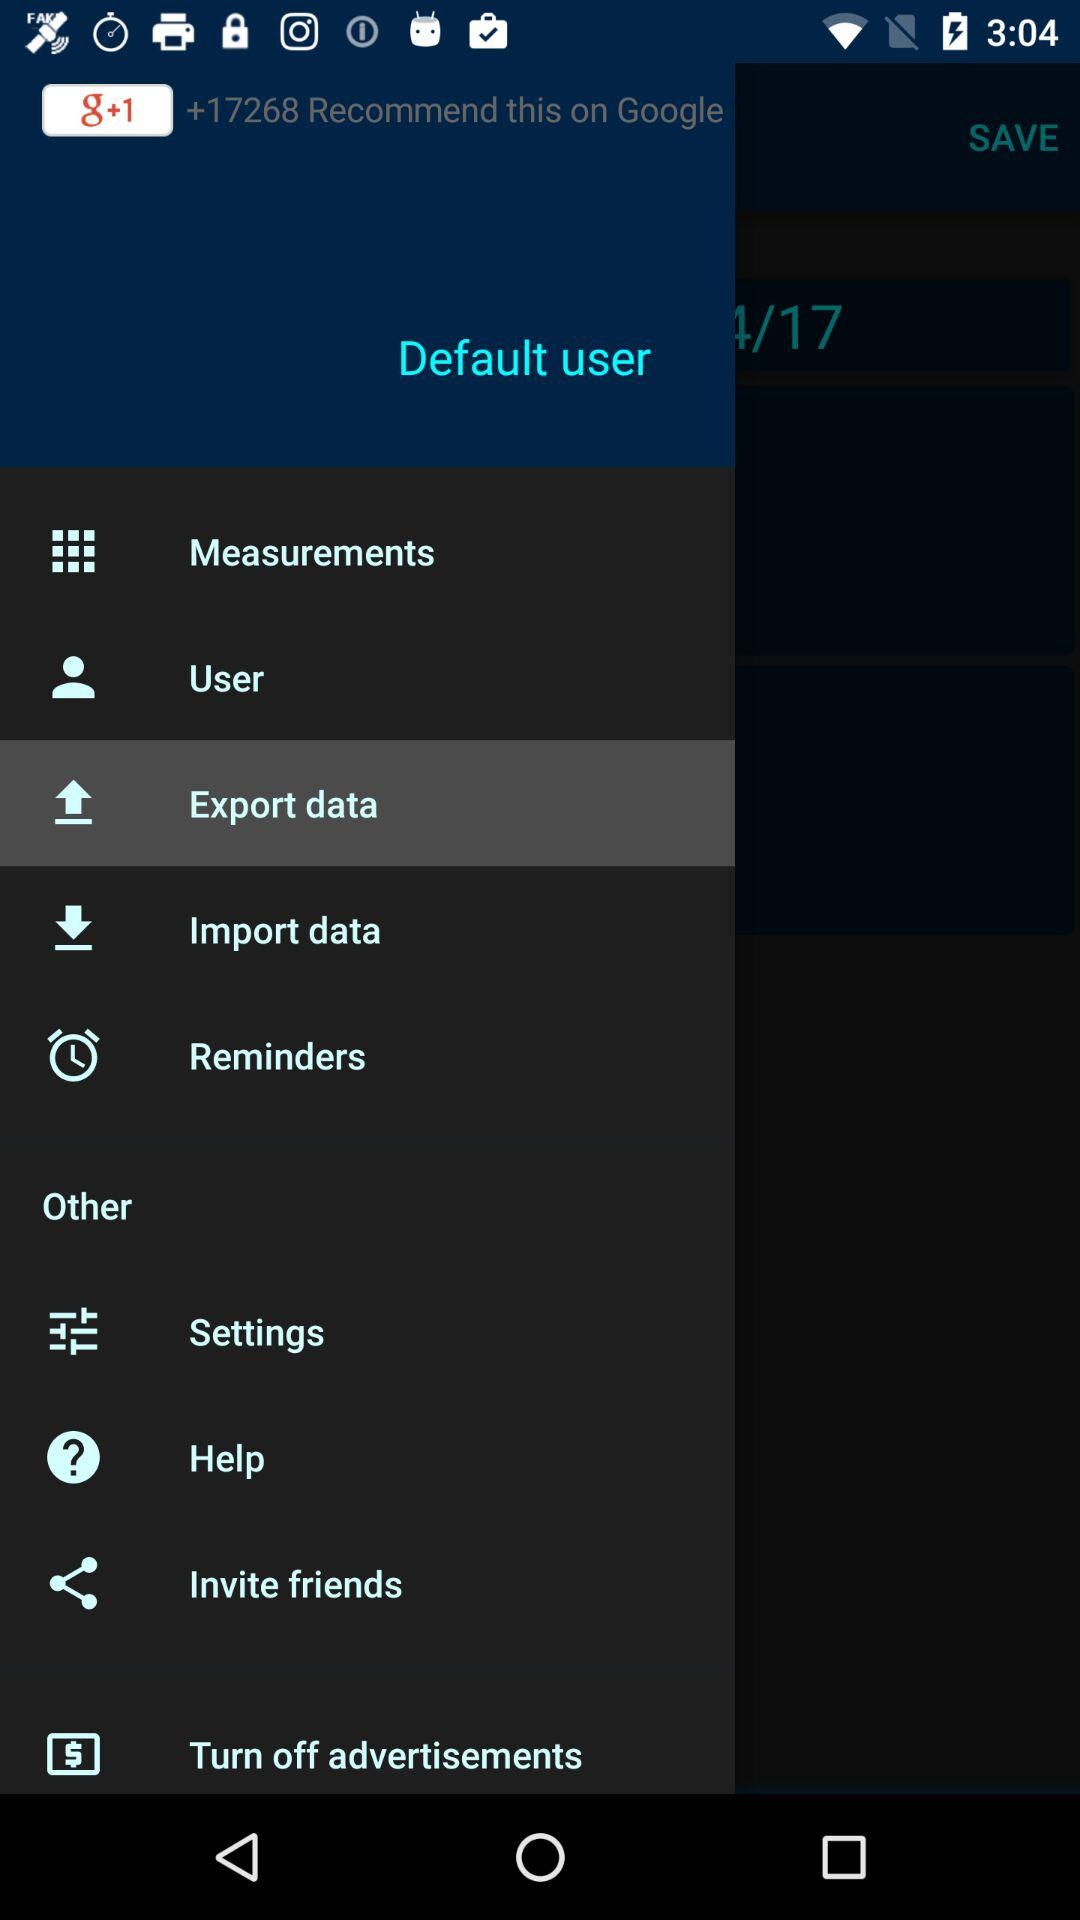Which option is selected? The selected option is "Export data". 